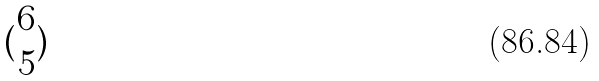Convert formula to latex. <formula><loc_0><loc_0><loc_500><loc_500>( \begin{matrix} 6 \\ 5 \end{matrix} )</formula> 